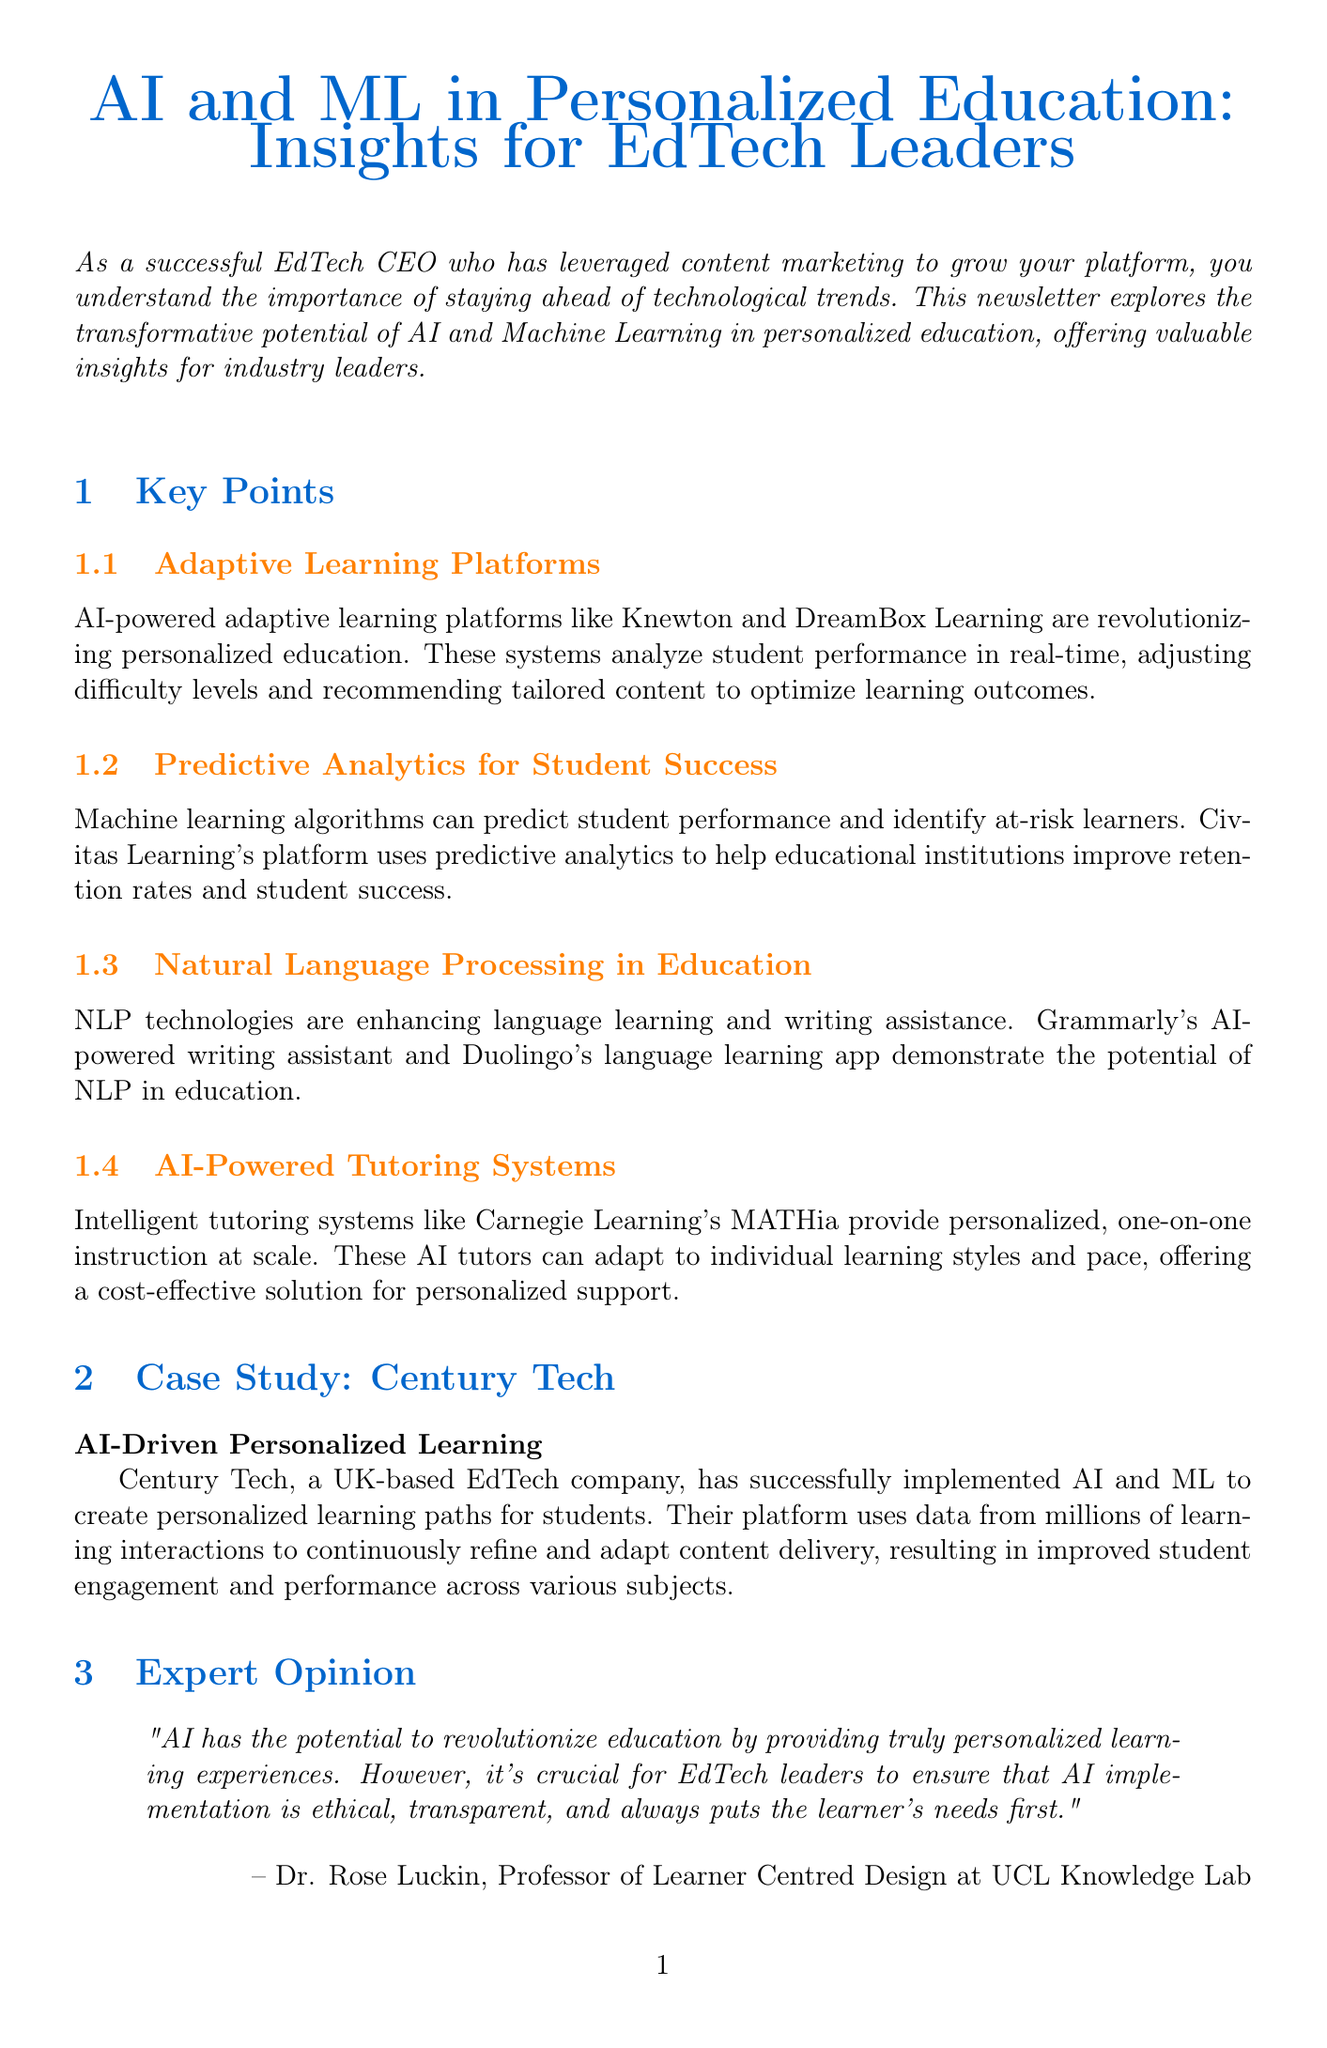What is the title of the newsletter? The title of the newsletter is stated at the beginning of the document.
Answer: AI and ML in Personalized Education: Insights for EdTech Leaders Who is the expert quoted in the newsletter? The expert's name is found in the expert opinion section of the document.
Answer: Dr. Rose Luckin What technology is used in adaptive learning platforms? The document specifies the technology utilized for adaptive learning.
Answer: AI-powered What is the main focus of Century Tech's platform? The case study outlines the focus of Century Tech's platform.
Answer: Personalized learning paths How many action items are listed in the document? The document includes a specific section with bullet points for action items.
Answer: Five What kind of analytics does Civitas Learning's platform use? The document discusses the type of analytics utilized by Civitas Learning's platform.
Answer: Predictive analytics What is the primary benefit of AI-powered tutoring systems mentioned? The document elucidates the main advantage of AI-powered tutoring systems.
Answer: Personalized instruction Which company is cited for enhancing language learning through NLP? The document references a specific company related to NLP in education.
Answer: Duolingo 